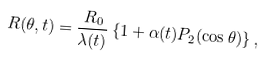Convert formula to latex. <formula><loc_0><loc_0><loc_500><loc_500>R ( \theta , t ) = \frac { R _ { 0 } } { \lambda ( t ) } \left \{ 1 + \alpha ( t ) P _ { 2 } ( \cos \theta ) \right \} ,</formula> 